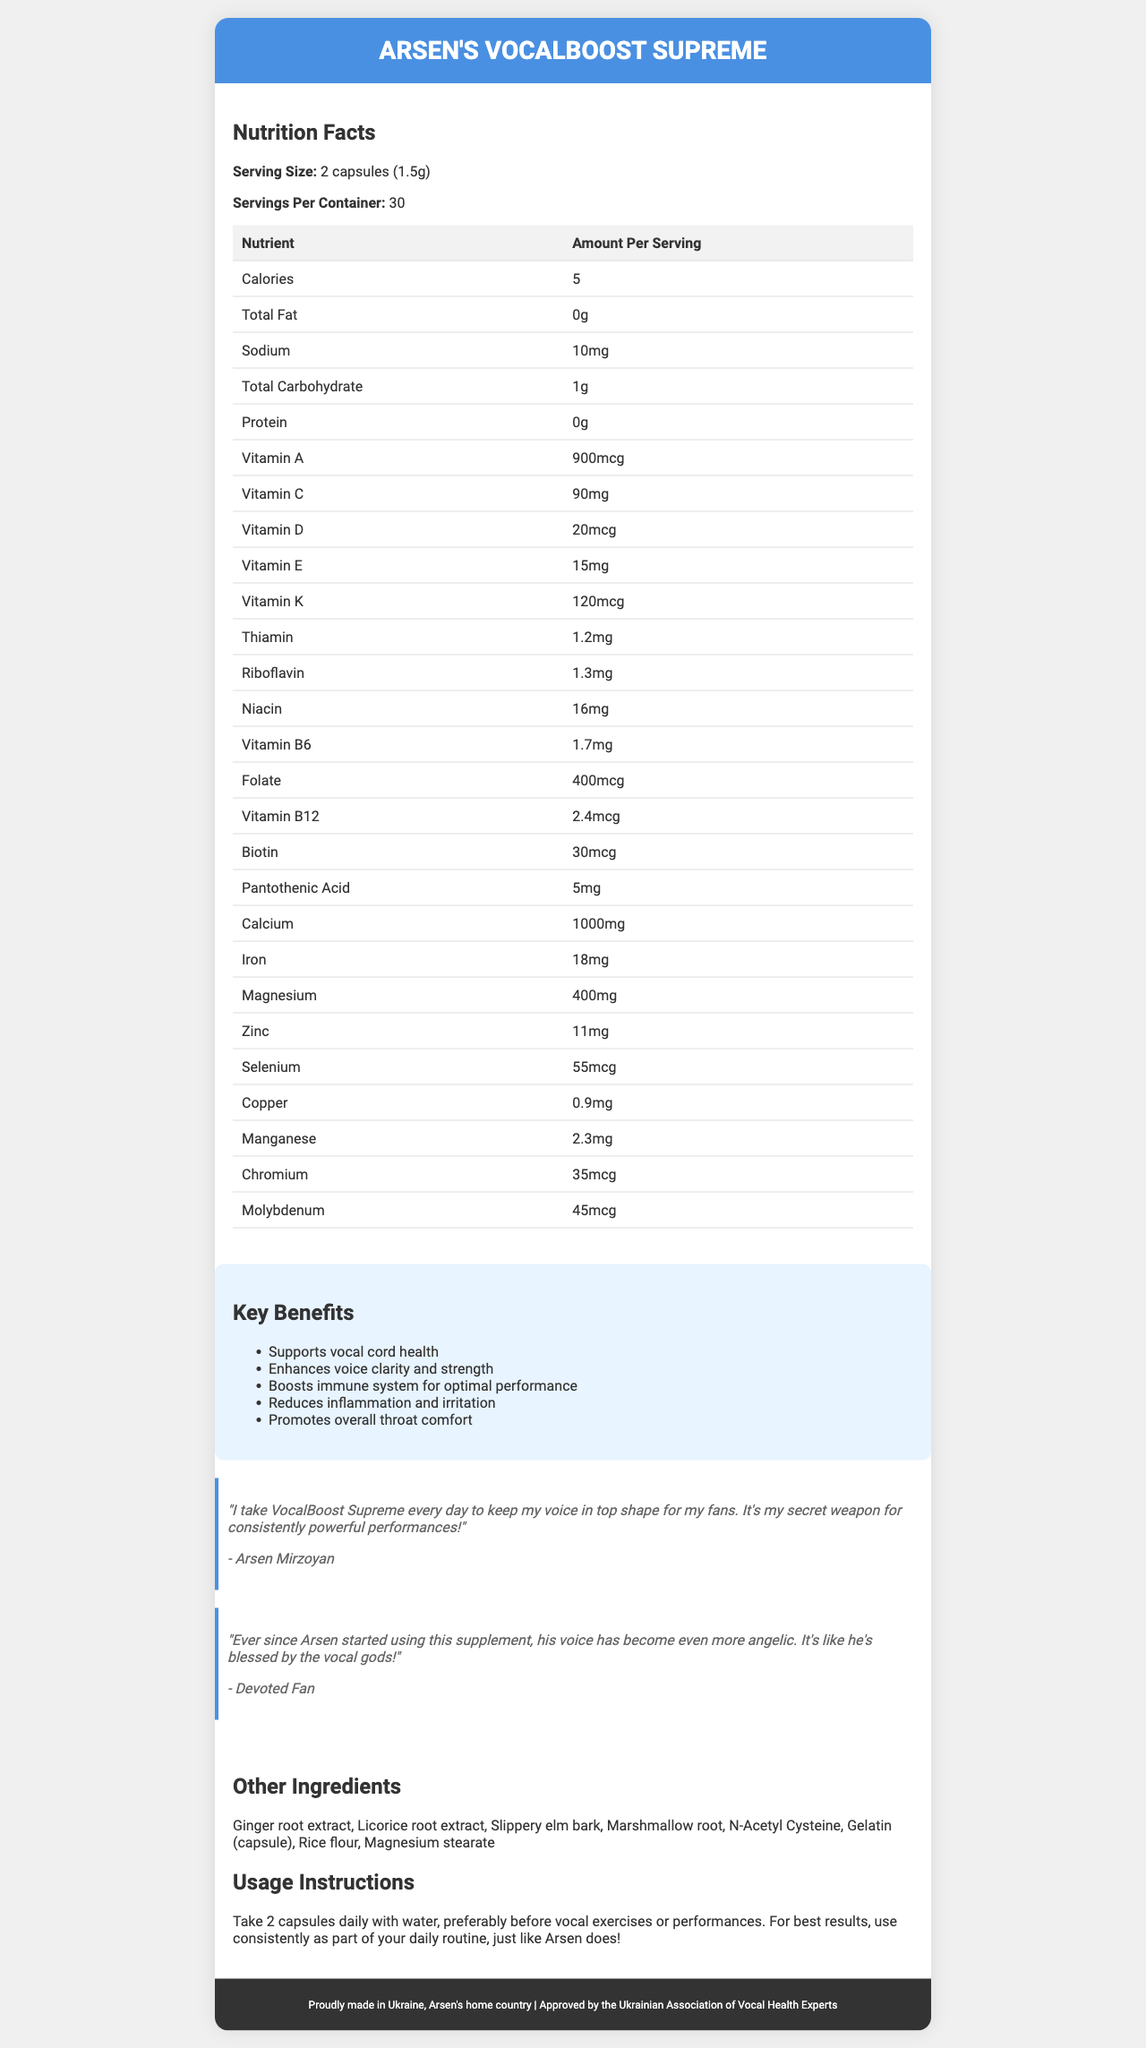What is the serving size of Arsen's VocalBoost Supreme? The serving size is mentioned as "2 capsules (1.5g)" in the document.
Answer: 2 capsules (1.5g) How many servings are there per container? The document states that there are 30 servings per container.
Answer: 30 How much calcium is in one serving of Arsen's VocalBoost Supreme? The nutrition facts list calcium as 1000mg per serving.
Answer: 1000mg What are the key benefits of taking Arsen's VocalBoost Supreme? The key benefits are listed under a dedicated section in the document.
Answer: Supports vocal cord health, Enhances voice clarity and strength, Boosts immune system for optimal performance, Reduces inflammation and irritation, Promotes overall throat comfort Which vitamin provides the highest amount in Arsen's VocalBoost Supreme? By examining the listed vitamin amounts, Vitamin A provides the highest at 900mcg.
Answer: Vitamin A (900mcg) What is the suggested use for Arsen's VocalBoost Supreme? A. Take with meals B. Take before bed C. Take 2 capsules daily with water D. Take on an empty stomach The usage instructions specify to "Take 2 capsules daily with water, preferably before vocal exercises or performances."
Answer: C. Take 2 capsules daily with water Which ingredient is not present in Arsen's VocalBoost Supreme? I. Vitamin A II. Ginger root extract III. Sugar IV. Magnesium stearate Sugar is not listed among the ingredients, while Vitamin A, Ginger root extract, and Magnesium stearate are present.
Answer: III. Sugar Does the product contain any protein? The document shows that the protein content per serving is 0g.
Answer: No Is Arsen's VocalBoost Supreme approved by any association? The document mentions that it is approved by the Ukrainian Association of Vocal Health Experts.
Answer: Yes Summarize the document in one sentence. The document details the product's purpose, key ingredients, benefits, and endorsements.
Answer: Arsen's VocalBoost Supreme is a dietary supplement designed to support vocal health, made in Ukraine, with key vitamins, minerals, herbal extracts, and approved by vocal health experts. Is there any information on potential side effects of taking Arsen's VocalBoost Supreme? The document does not provide any information on potential side effects.
Answer: Not enough information 